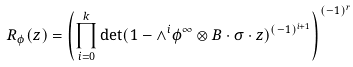<formula> <loc_0><loc_0><loc_500><loc_500>R _ { \phi } ( z ) = \left ( \prod _ { i = 0 } ^ { k } \det ( 1 - \wedge ^ { i } \phi ^ { \infty } \otimes B \cdot \sigma \cdot z ) ^ { ( - 1 ) ^ { i + 1 } } \right ) ^ { ( - 1 ) ^ { r } }</formula> 